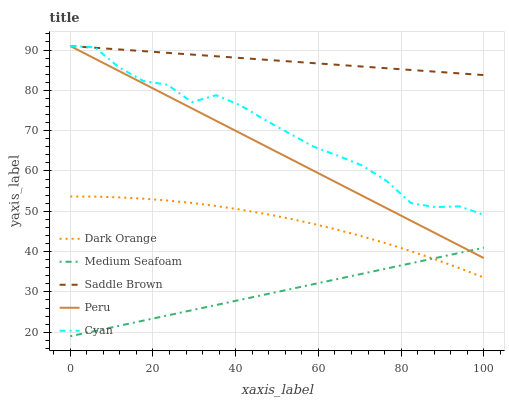Does Medium Seafoam have the minimum area under the curve?
Answer yes or no. Yes. Does Saddle Brown have the maximum area under the curve?
Answer yes or no. Yes. Does Cyan have the minimum area under the curve?
Answer yes or no. No. Does Cyan have the maximum area under the curve?
Answer yes or no. No. Is Peru the smoothest?
Answer yes or no. Yes. Is Cyan the roughest?
Answer yes or no. Yes. Is Medium Seafoam the smoothest?
Answer yes or no. No. Is Medium Seafoam the roughest?
Answer yes or no. No. Does Medium Seafoam have the lowest value?
Answer yes or no. Yes. Does Cyan have the lowest value?
Answer yes or no. No. Does Saddle Brown have the highest value?
Answer yes or no. Yes. Does Medium Seafoam have the highest value?
Answer yes or no. No. Is Medium Seafoam less than Saddle Brown?
Answer yes or no. Yes. Is Saddle Brown greater than Medium Seafoam?
Answer yes or no. Yes. Does Peru intersect Cyan?
Answer yes or no. Yes. Is Peru less than Cyan?
Answer yes or no. No. Is Peru greater than Cyan?
Answer yes or no. No. Does Medium Seafoam intersect Saddle Brown?
Answer yes or no. No. 